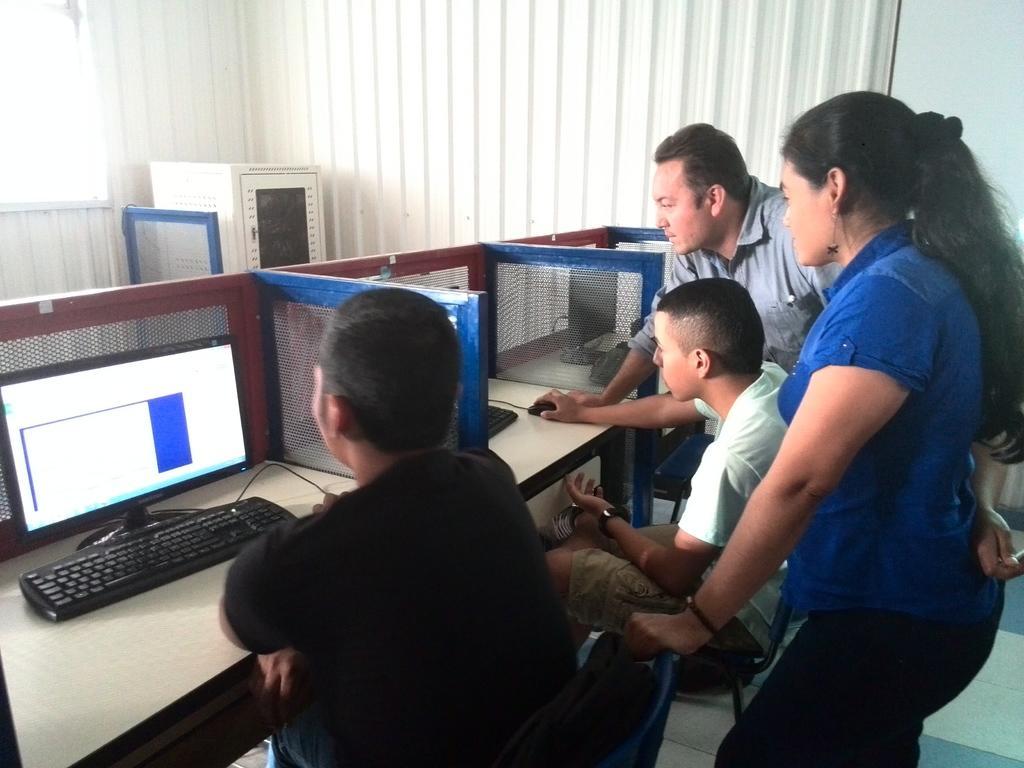Could you give a brief overview of what you see in this image? In this image there are four persons. On the left side the man is sitting on the chair in front of a system. At the background we can see a curtains. 